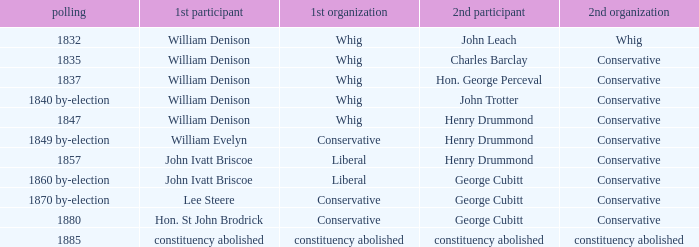Which party with an 1835 election has 1st member William Denison? Conservative. 